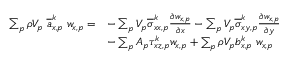<formula> <loc_0><loc_0><loc_500><loc_500>\begin{array} { r l } { \sum _ { p } \rho V _ { p } \, \overline { a } _ { x , p } ^ { k } \, w _ { x , p } = } & { - \sum _ { p } V _ { p } \overline { \sigma } _ { x x , p } ^ { k } \frac { \partial w _ { x , p } } { \partial x } - \sum _ { p } V _ { p } \overline { \sigma } _ { x y , p } ^ { k } \frac { \partial w _ { x , p } } { \partial y } } \\ & { - \sum _ { p } A _ { p } \tau _ { x z , p } ^ { k } w _ { x , p } + \sum _ { p } \rho V _ { p } b _ { x , p } ^ { k } \, w _ { x , p } } \end{array}</formula> 